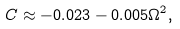<formula> <loc_0><loc_0><loc_500><loc_500>C \approx - 0 . 0 2 3 - 0 . 0 0 5 \Omega ^ { 2 } ,</formula> 